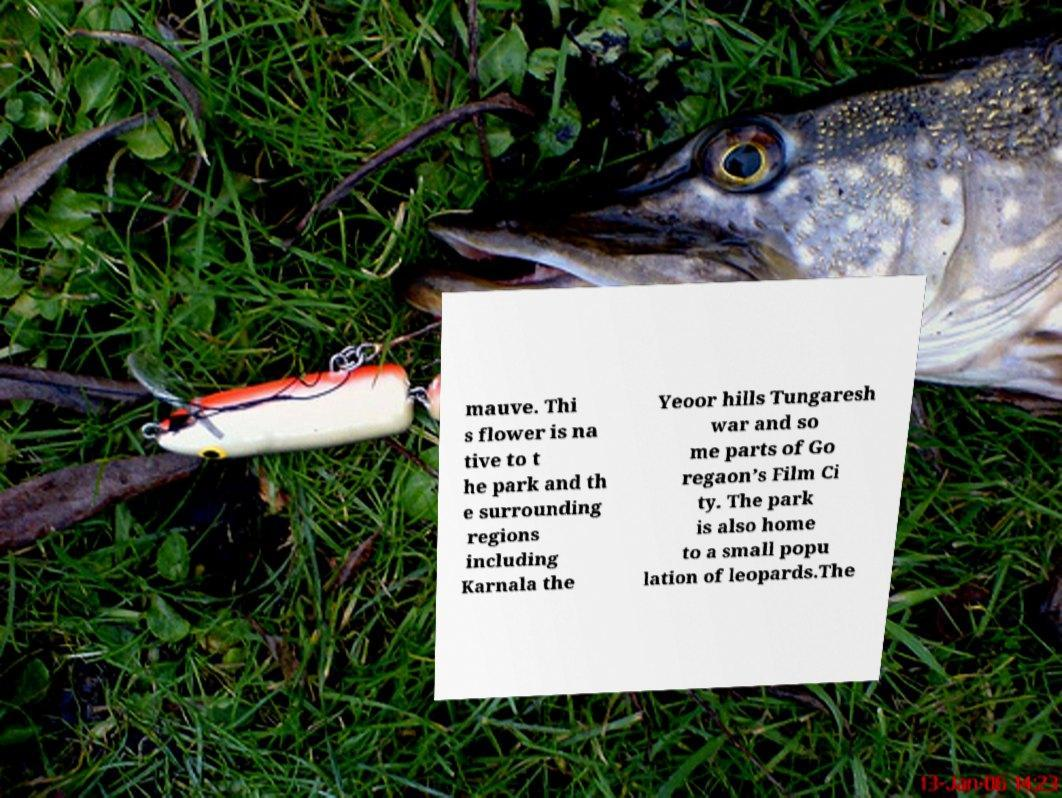Please identify and transcribe the text found in this image. mauve. Thi s flower is na tive to t he park and th e surrounding regions including Karnala the Yeoor hills Tungaresh war and so me parts of Go regaon’s Film Ci ty. The park is also home to a small popu lation of leopards.The 